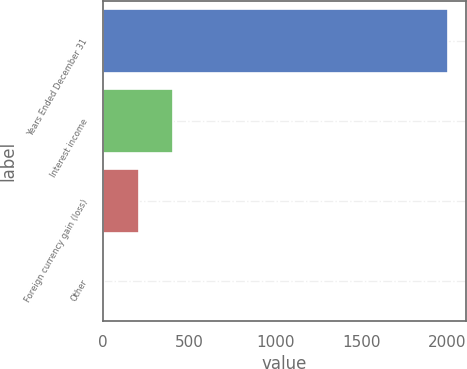Convert chart to OTSL. <chart><loc_0><loc_0><loc_500><loc_500><bar_chart><fcel>Years Ended December 31<fcel>Interest income<fcel>Foreign currency gain (loss)<fcel>Other<nl><fcel>2005<fcel>409<fcel>209.5<fcel>10<nl></chart> 